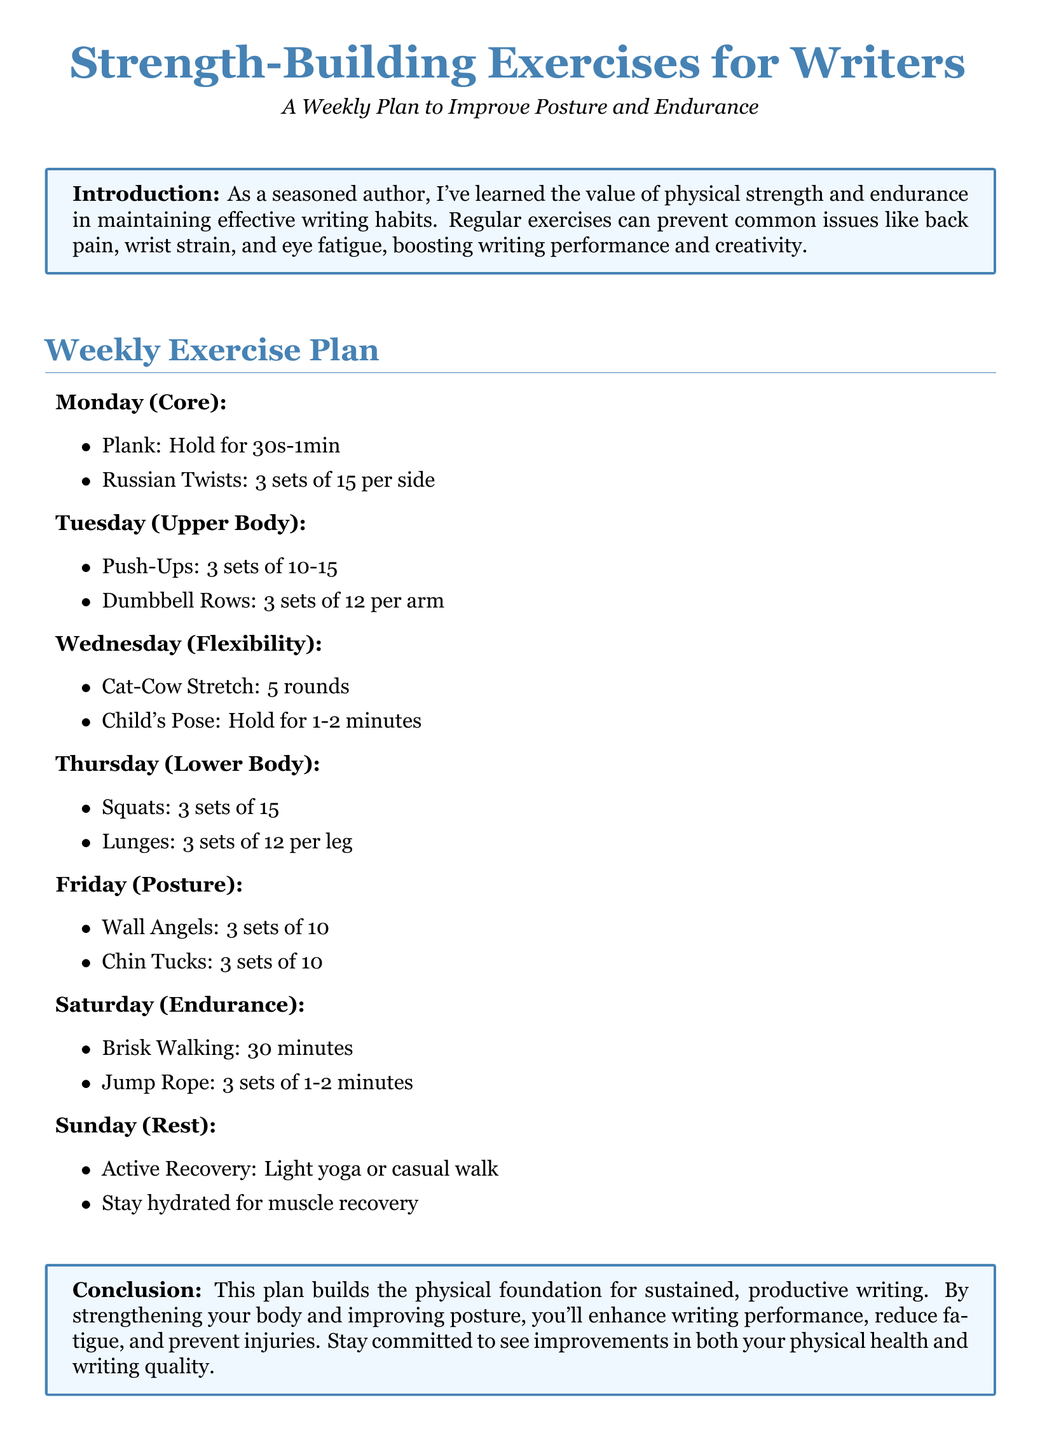What exercises are included on Monday? The exercises listed for Monday are Plank and Russian Twists.
Answer: Plank, Russian Twists How long should the Plank be held? The document states the Plank should be held for 30 seconds to 1 minute.
Answer: 30s-1min How many sets of Push-Ups are recommended? The document specifies 3 sets of Push-Ups.
Answer: 3 sets What is suggested for Sunday? The activities suggested for Sunday include Active Recovery and hydration advice.
Answer: Active Recovery, Stay hydrated How many rounds of Cat-Cow Stretch are recommended? The document recommends performing 5 rounds of Cat-Cow Stretch.
Answer: 5 rounds What is the focus of the exercise plan? The focus of this plan is to improve posture and endurance for writers.
Answer: Improve posture and endurance What type of recovery is suggested on Sunday? The document suggests light yoga or a casual walk for the recovery on Sunday.
Answer: Light yoga or casual walk What is the purpose of strengthening exercises according to the document? The document mentions that these strengthening exercises enhance writing performance and reduce fatigue.
Answer: Enhance writing performance, reduce fatigue 